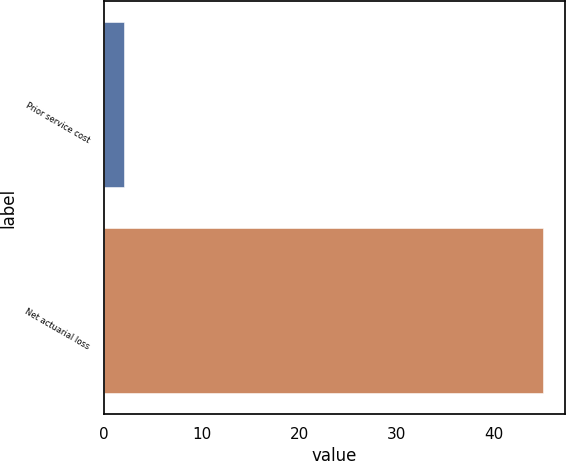Convert chart to OTSL. <chart><loc_0><loc_0><loc_500><loc_500><bar_chart><fcel>Prior service cost<fcel>Net actuarial loss<nl><fcel>2<fcel>45<nl></chart> 